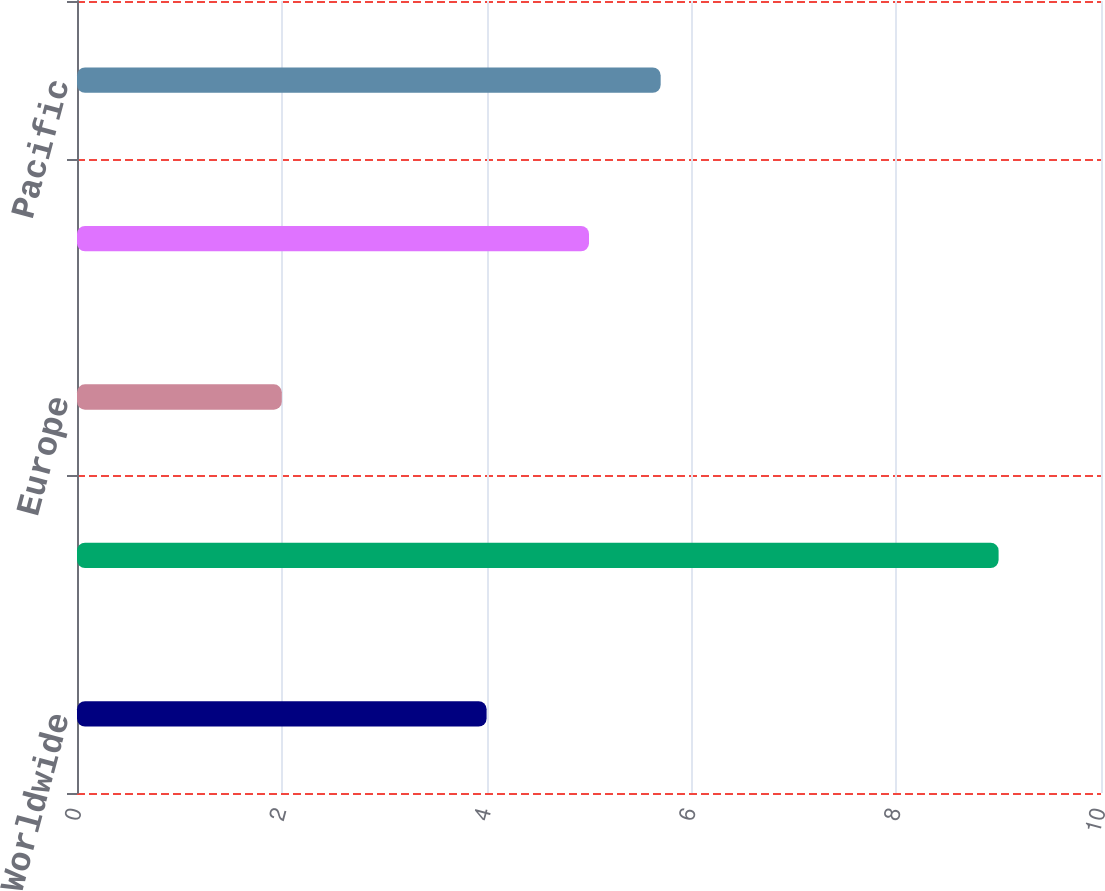<chart> <loc_0><loc_0><loc_500><loc_500><bar_chart><fcel>Worldwide<fcel>Eurasia & Africa<fcel>Europe<fcel>Latin America<fcel>Pacific<nl><fcel>4<fcel>9<fcel>2<fcel>5<fcel>5.7<nl></chart> 